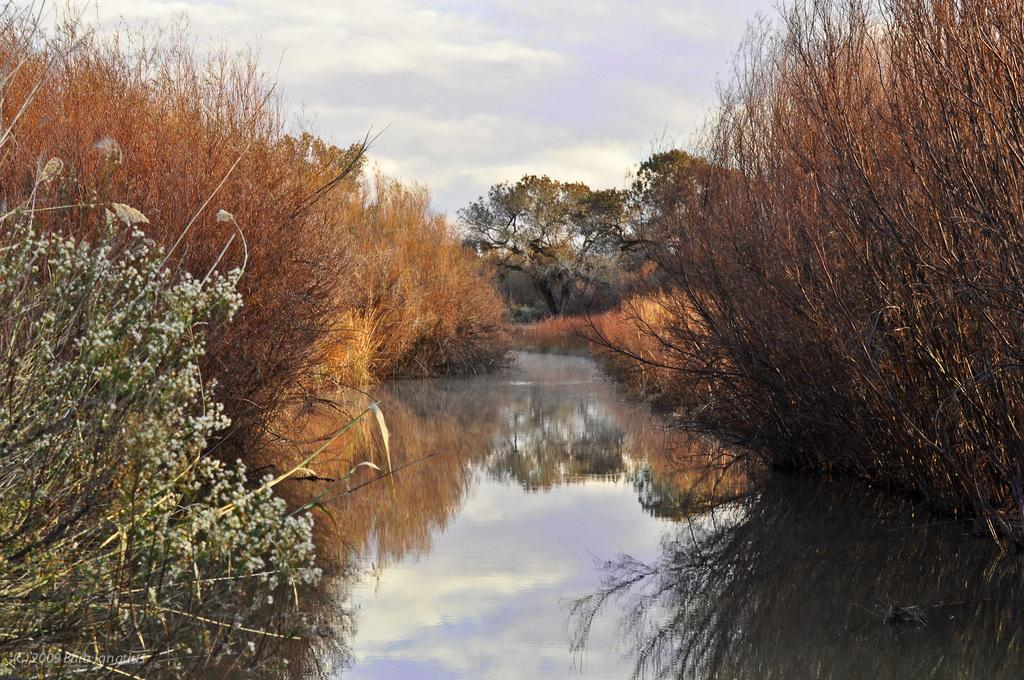What type of vegetation can be seen on both sides of the image? There are trees and plants on the right side and the left side of the image. What is located in the center of the image? There is water in the center of the image. What can be seen in the background of the image? Trees, the sky, and clouds are visible in the background of the image. What shape are the dinosaurs in the image? There are no dinosaurs present in the image. What type of pleasure can be seen in the image? The image does not depict any specific pleasure or emotion; it shows trees, plants, water, and a sky with clouds. 